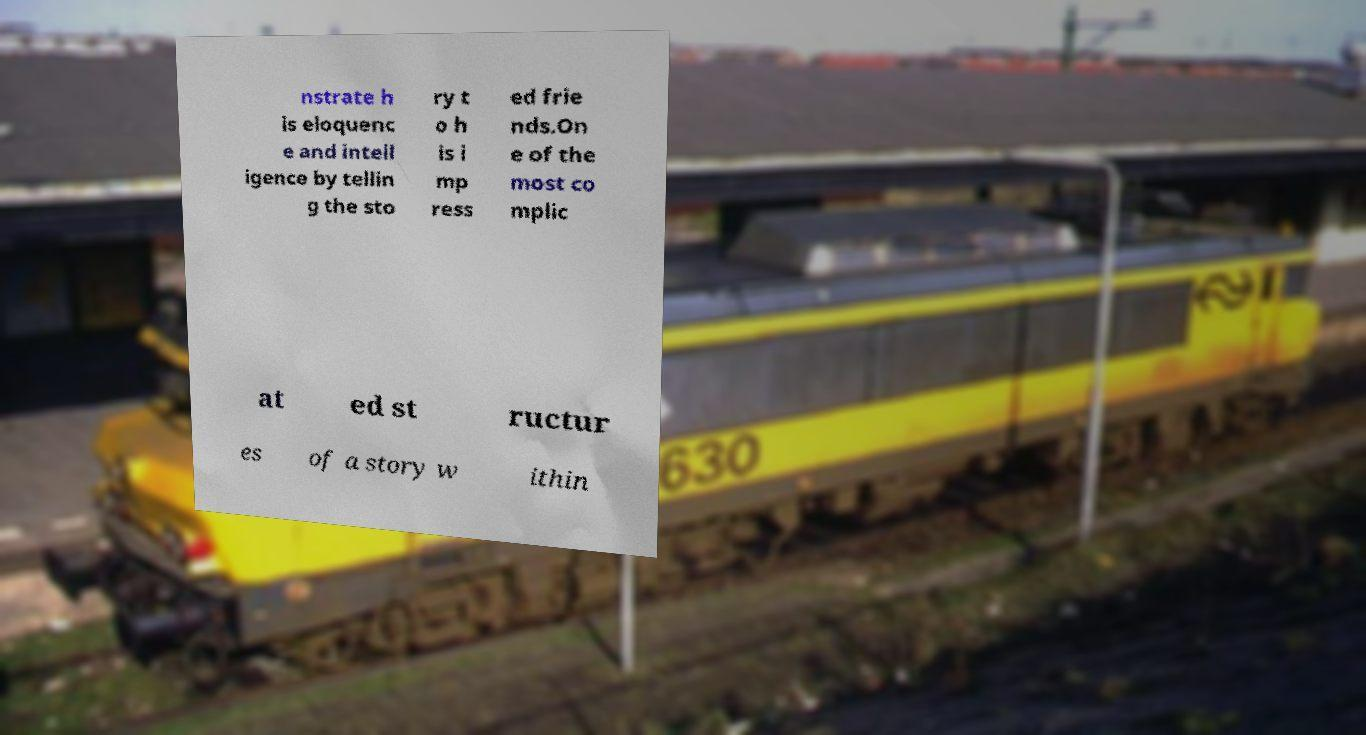There's text embedded in this image that I need extracted. Can you transcribe it verbatim? nstrate h is eloquenc e and intell igence by tellin g the sto ry t o h is i mp ress ed frie nds.On e of the most co mplic at ed st ructur es of a story w ithin 